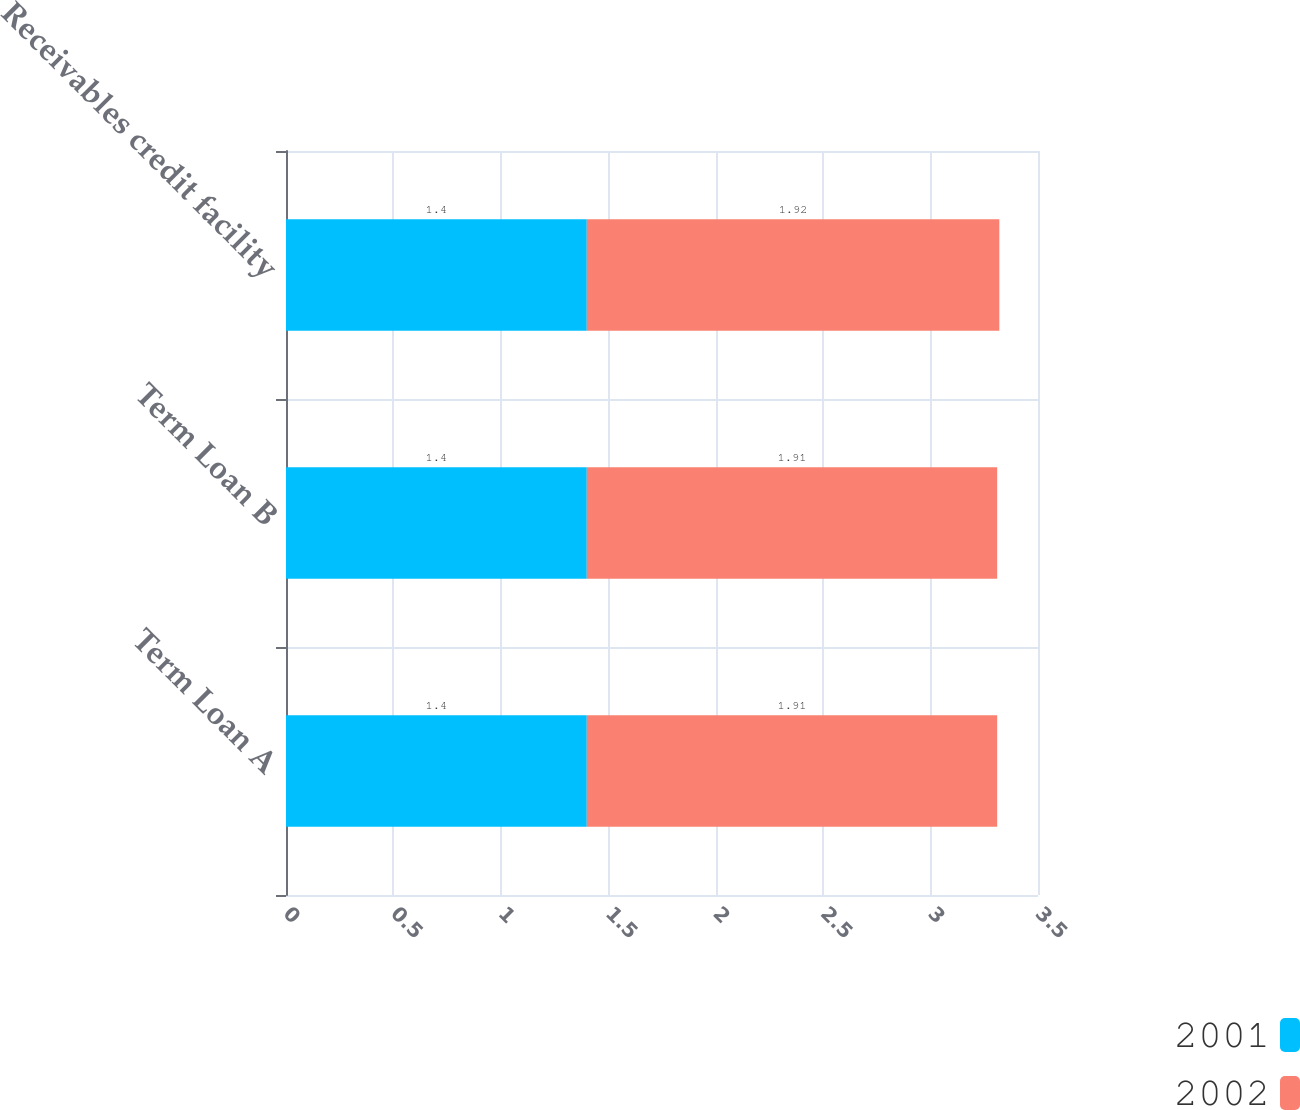Convert chart to OTSL. <chart><loc_0><loc_0><loc_500><loc_500><stacked_bar_chart><ecel><fcel>Term Loan A<fcel>Term Loan B<fcel>Receivables credit facility<nl><fcel>2001<fcel>1.4<fcel>1.4<fcel>1.4<nl><fcel>2002<fcel>1.91<fcel>1.91<fcel>1.92<nl></chart> 